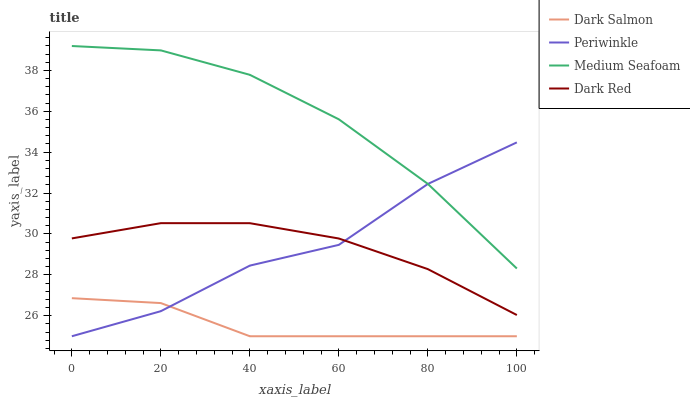Does Periwinkle have the minimum area under the curve?
Answer yes or no. No. Does Periwinkle have the maximum area under the curve?
Answer yes or no. No. Is Dark Salmon the smoothest?
Answer yes or no. No. Is Dark Salmon the roughest?
Answer yes or no. No. Does Medium Seafoam have the lowest value?
Answer yes or no. No. Does Periwinkle have the highest value?
Answer yes or no. No. Is Dark Salmon less than Dark Red?
Answer yes or no. Yes. Is Medium Seafoam greater than Dark Salmon?
Answer yes or no. Yes. Does Dark Salmon intersect Dark Red?
Answer yes or no. No. 